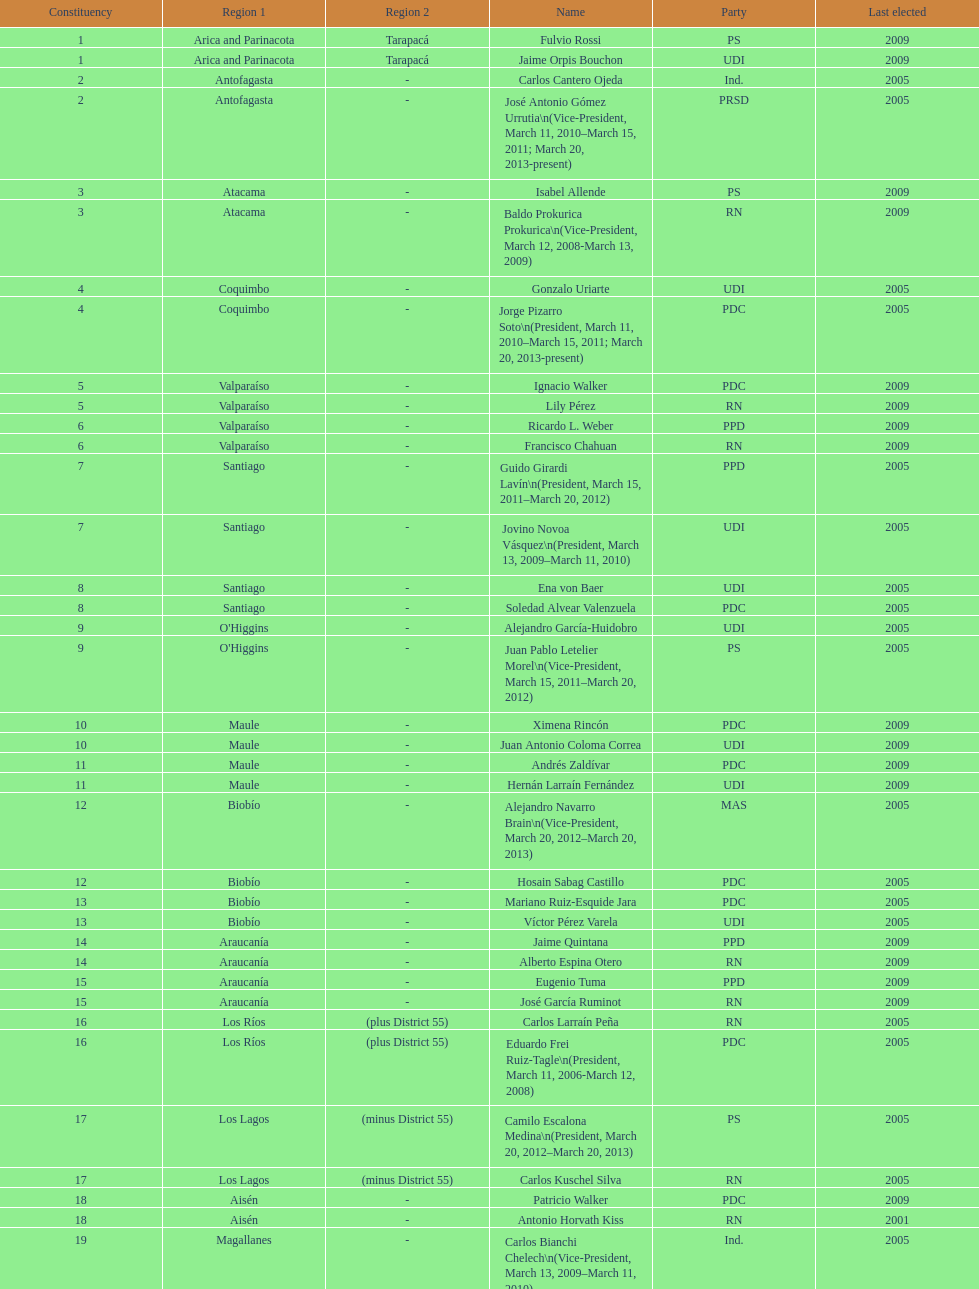How long was baldo prokurica prokurica vice-president? 1 year. 